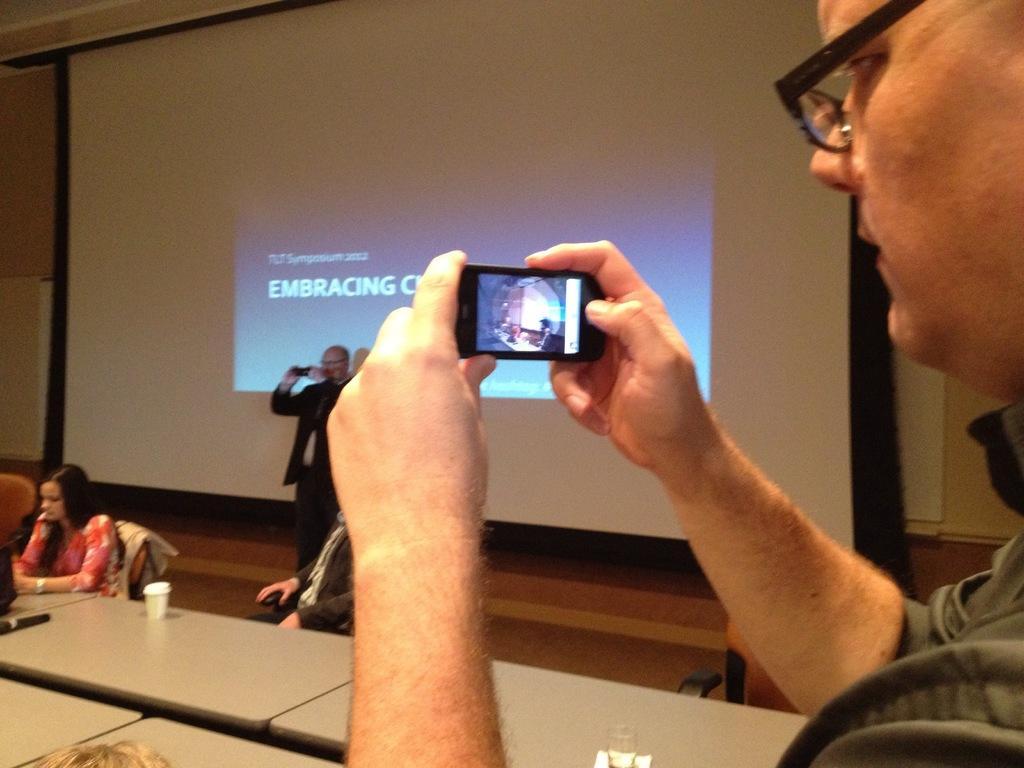Please provide a concise description of this image. In this image I can see one person is holding the mobile. In front of him there are people sitting and one person is standing in-front of the screen. 